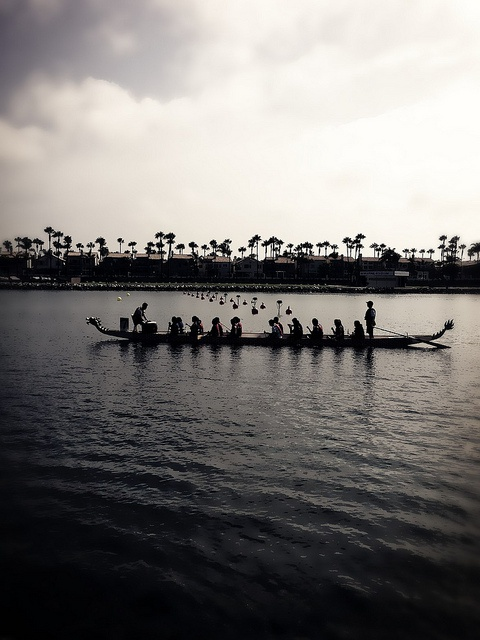Describe the objects in this image and their specific colors. I can see boat in gray, black, and darkgray tones, people in gray, black, darkgray, and lightgray tones, people in gray, black, and darkgray tones, people in gray, black, and darkgray tones, and people in black, gray, and darkgray tones in this image. 